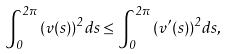<formula> <loc_0><loc_0><loc_500><loc_500>\int _ { 0 } ^ { 2 \pi } { ( v ( s ) ) ^ { 2 } d s } \leq \int _ { 0 } ^ { 2 \pi } { ( v ^ { \prime } ( s ) ) ^ { 2 } d s } ,</formula> 